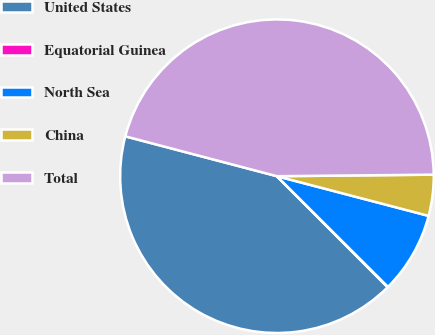Convert chart. <chart><loc_0><loc_0><loc_500><loc_500><pie_chart><fcel>United States<fcel>Equatorial Guinea<fcel>North Sea<fcel>China<fcel>Total<nl><fcel>41.57%<fcel>0.05%<fcel>8.4%<fcel>4.23%<fcel>45.75%<nl></chart> 